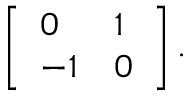<formula> <loc_0><loc_0><loc_500><loc_500>\left [ \begin{array} { l l } { 0 } & { 1 } \\ { - 1 } & { 0 } \end{array} \right ] .</formula> 